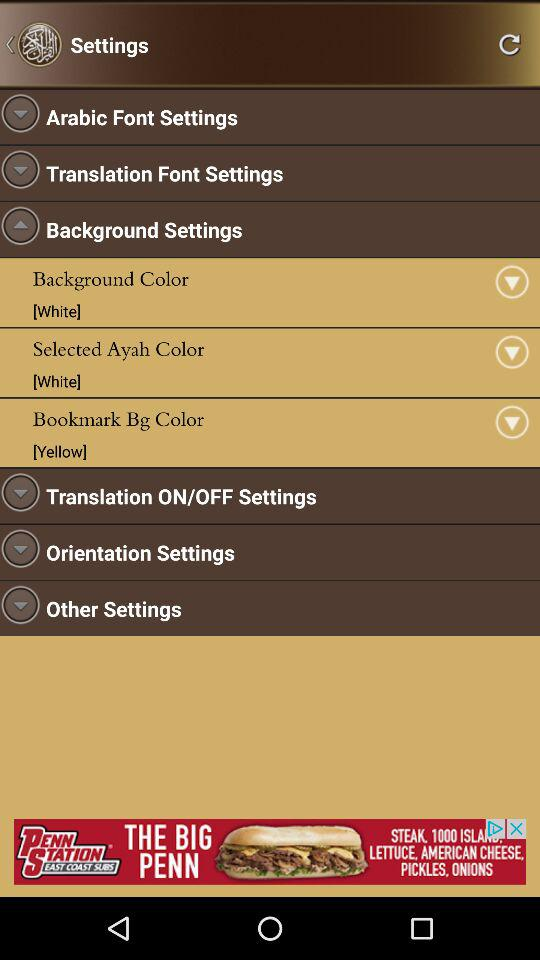What is the selected background color? The selected background color is white. 